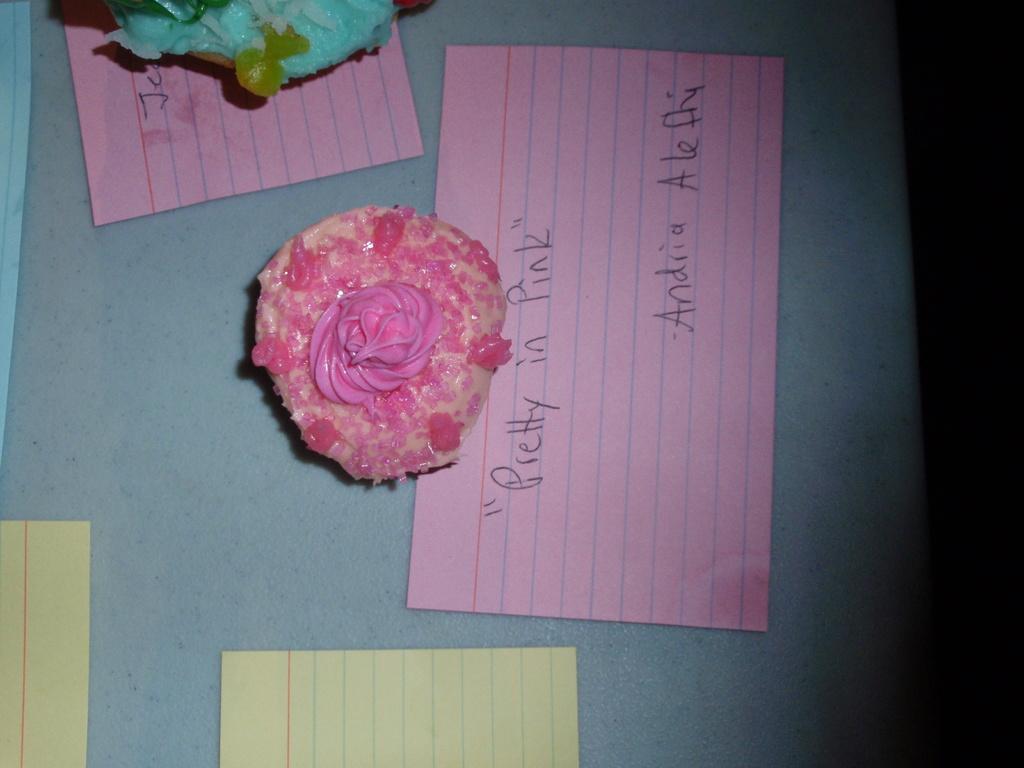Please provide a concise description of this image. There is a cake with pink color cream on that. Below that there is a paper with something written on that. Also there are many other papers. And a cake on the top left side. 